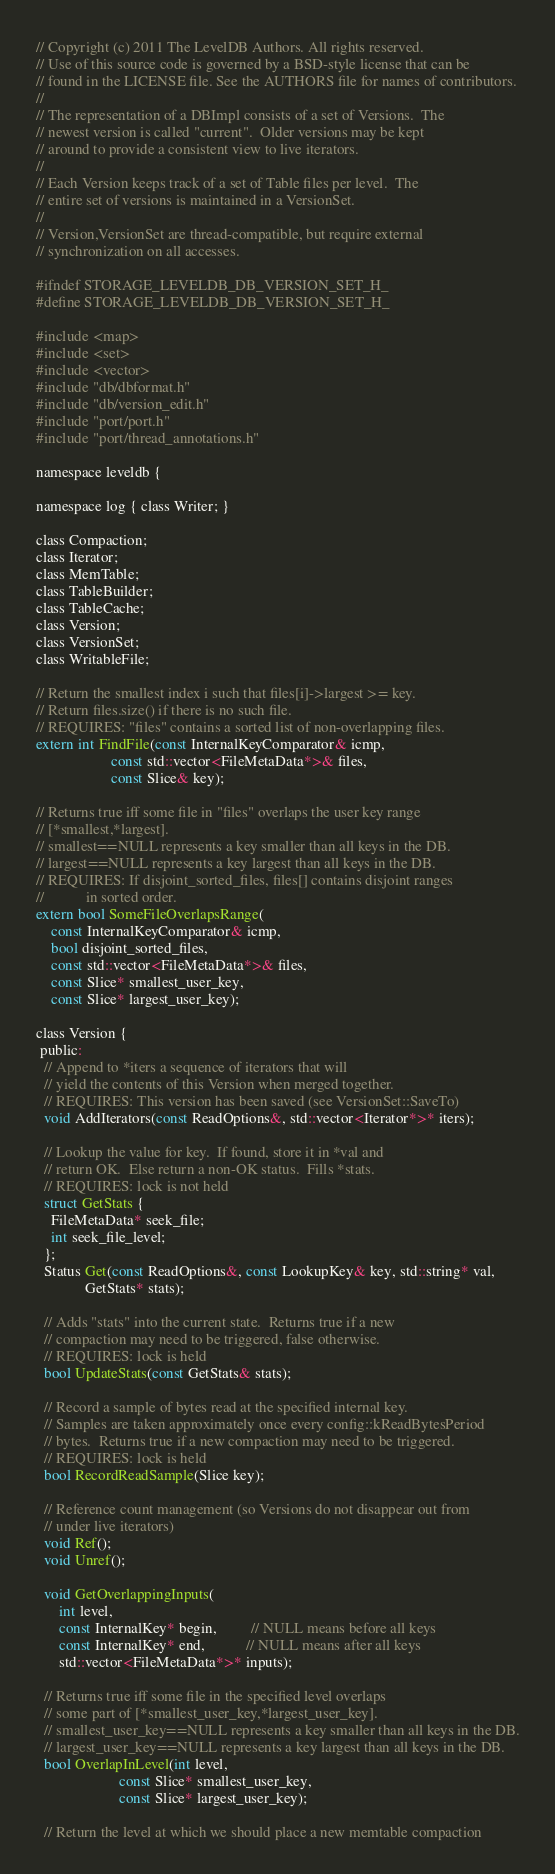Convert code to text. <code><loc_0><loc_0><loc_500><loc_500><_C_>// Copyright (c) 2011 The LevelDB Authors. All rights reserved.
// Use of this source code is governed by a BSD-style license that can be
// found in the LICENSE file. See the AUTHORS file for names of contributors.
//
// The representation of a DBImpl consists of a set of Versions.  The
// newest version is called "current".  Older versions may be kept
// around to provide a consistent view to live iterators.
//
// Each Version keeps track of a set of Table files per level.  The
// entire set of versions is maintained in a VersionSet.
//
// Version,VersionSet are thread-compatible, but require external
// synchronization on all accesses.

#ifndef STORAGE_LEVELDB_DB_VERSION_SET_H_
#define STORAGE_LEVELDB_DB_VERSION_SET_H_

#include <map>
#include <set>
#include <vector>
#include "db/dbformat.h"
#include "db/version_edit.h"
#include "port/port.h"
#include "port/thread_annotations.h"

namespace leveldb {

namespace log { class Writer; }

class Compaction;
class Iterator;
class MemTable;
class TableBuilder;
class TableCache;
class Version;
class VersionSet;
class WritableFile;

// Return the smallest index i such that files[i]->largest >= key.
// Return files.size() if there is no such file.
// REQUIRES: "files" contains a sorted list of non-overlapping files.
extern int FindFile(const InternalKeyComparator& icmp,
                    const std::vector<FileMetaData*>& files,
                    const Slice& key);

// Returns true iff some file in "files" overlaps the user key range
// [*smallest,*largest].
// smallest==NULL represents a key smaller than all keys in the DB.
// largest==NULL represents a key largest than all keys in the DB.
// REQUIRES: If disjoint_sorted_files, files[] contains disjoint ranges
//           in sorted order.
extern bool SomeFileOverlapsRange(
    const InternalKeyComparator& icmp,
    bool disjoint_sorted_files,
    const std::vector<FileMetaData*>& files,
    const Slice* smallest_user_key,
    const Slice* largest_user_key);

class Version {
 public:
  // Append to *iters a sequence of iterators that will
  // yield the contents of this Version when merged together.
  // REQUIRES: This version has been saved (see VersionSet::SaveTo)
  void AddIterators(const ReadOptions&, std::vector<Iterator*>* iters);

  // Lookup the value for key.  If found, store it in *val and
  // return OK.  Else return a non-OK status.  Fills *stats.
  // REQUIRES: lock is not held
  struct GetStats {
    FileMetaData* seek_file;
    int seek_file_level;
  };
  Status Get(const ReadOptions&, const LookupKey& key, std::string* val,
             GetStats* stats);

  // Adds "stats" into the current state.  Returns true if a new
  // compaction may need to be triggered, false otherwise.
  // REQUIRES: lock is held
  bool UpdateStats(const GetStats& stats);

  // Record a sample of bytes read at the specified internal key.
  // Samples are taken approximately once every config::kReadBytesPeriod
  // bytes.  Returns true if a new compaction may need to be triggered.
  // REQUIRES: lock is held
  bool RecordReadSample(Slice key);

  // Reference count management (so Versions do not disappear out from
  // under live iterators)
  void Ref();
  void Unref();

  void GetOverlappingInputs(
      int level,
      const InternalKey* begin,         // NULL means before all keys
      const InternalKey* end,           // NULL means after all keys
      std::vector<FileMetaData*>* inputs);

  // Returns true iff some file in the specified level overlaps
  // some part of [*smallest_user_key,*largest_user_key].
  // smallest_user_key==NULL represents a key smaller than all keys in the DB.
  // largest_user_key==NULL represents a key largest than all keys in the DB.
  bool OverlapInLevel(int level,
                      const Slice* smallest_user_key,
                      const Slice* largest_user_key);

  // Return the level at which we should place a new memtable compaction</code> 